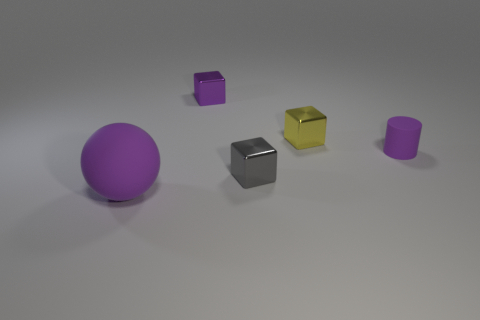Subtract all purple cubes. Subtract all yellow balls. How many cubes are left? 2 Add 3 tiny yellow balls. How many objects exist? 8 Subtract all cubes. How many objects are left? 2 Add 1 tiny yellow metal cubes. How many tiny yellow metal cubes are left? 2 Add 5 gray metallic cylinders. How many gray metallic cylinders exist? 5 Subtract 0 cyan blocks. How many objects are left? 5 Subtract all matte spheres. Subtract all metallic things. How many objects are left? 1 